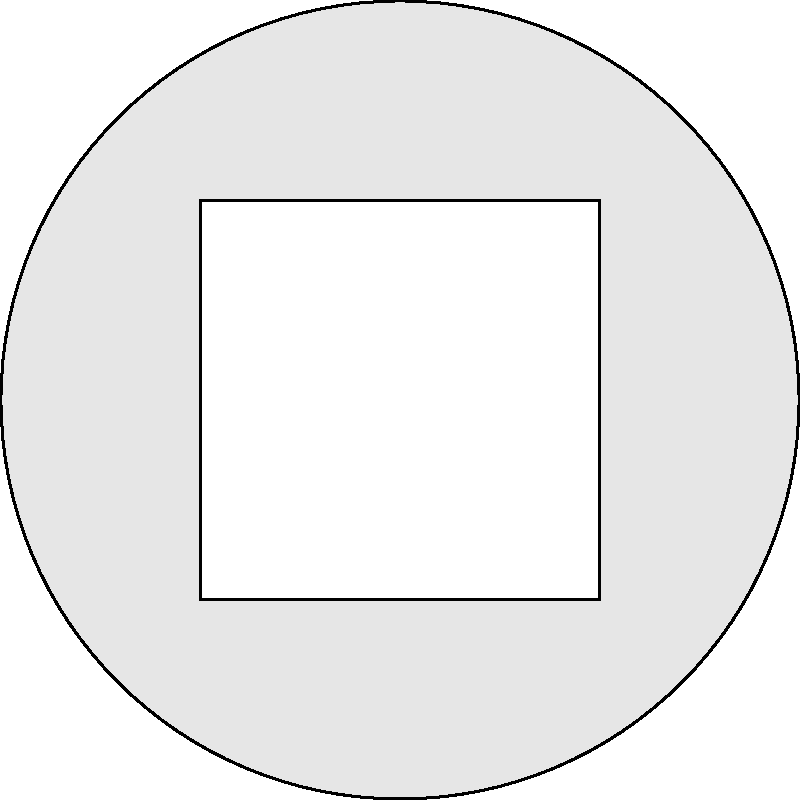Look at the image above. A circle is shown with a square inside it. The square's sides are half the length of the circle's diameter. Estimate the percentage of the circle's area that is shaded (the gray area outside the square). Let's approach this step-by-step:

1. First, we need to understand what we're looking at. We have a circle with a square inside it. The square's sides are half the length of the circle's diameter.

2. The area we're interested in is the shaded area, which is the circle minus the square.

3. To estimate this, let's think about the proportions:
   - The circle takes up the entire space.
   - The square takes up a significant portion of the circle, but not all of it.
   - The shaded area is what's left around the edges.

4. We can see that the shaded area forms a sort of "ring" around the square.

5. This "ring" doesn't look as large as the square itself, but it's not tiny either.

6. A reasonable estimate might be that the shaded area is about 1/3 to 1/2 of the total circle area.

7. Converting this to a percentage, we could estimate that the shaded area is about 33% to 50% of the circle.

8. Given the visual proportions, an estimate of about 40% seems reasonable.

(Note: The actual mathematical calculation would show that the shaded area is about 21.5% of the circle, but for a visual estimate without using formulas, 40% is a reasonable guess.)
Answer: Approximately 40% 